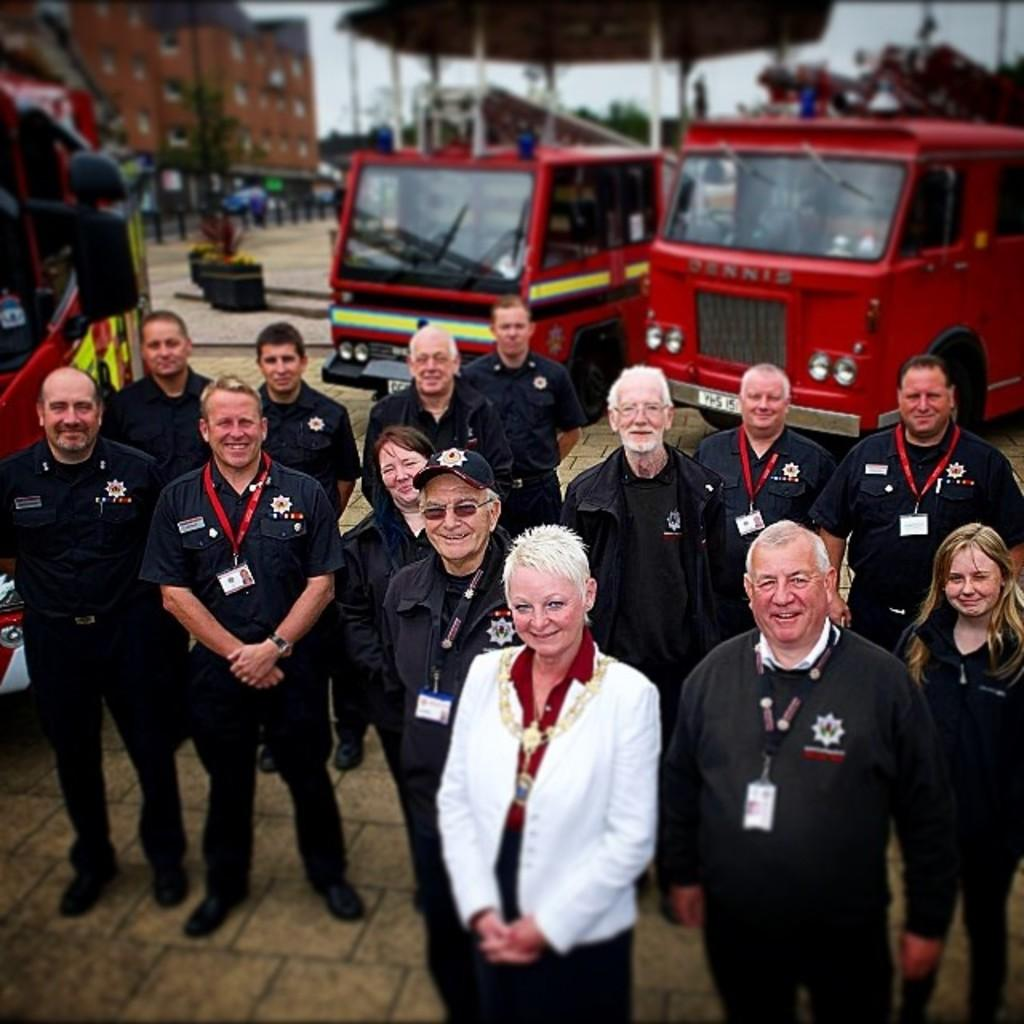What are the people in the image doing? The persons standing on the ground are likely engaged in some activity or standing idly. What can be seen in the distance behind the people? In the background, there are vehicles, buildings, trees, poles, a road, and the sky. Can you describe the environment in the image? The image shows a scene with people, vehicles, buildings, trees, poles, a road, and the sky, suggesting an urban or suburban setting. Where is the faucet located in the image? There is no faucet present in the image. What type of food is being prepared in the image? There is no food preparation visible in the image. 